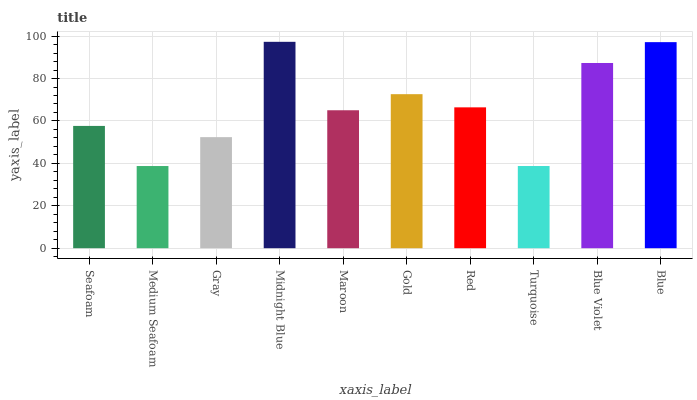Is Medium Seafoam the minimum?
Answer yes or no. Yes. Is Midnight Blue the maximum?
Answer yes or no. Yes. Is Gray the minimum?
Answer yes or no. No. Is Gray the maximum?
Answer yes or no. No. Is Gray greater than Medium Seafoam?
Answer yes or no. Yes. Is Medium Seafoam less than Gray?
Answer yes or no. Yes. Is Medium Seafoam greater than Gray?
Answer yes or no. No. Is Gray less than Medium Seafoam?
Answer yes or no. No. Is Red the high median?
Answer yes or no. Yes. Is Maroon the low median?
Answer yes or no. Yes. Is Midnight Blue the high median?
Answer yes or no. No. Is Blue the low median?
Answer yes or no. No. 